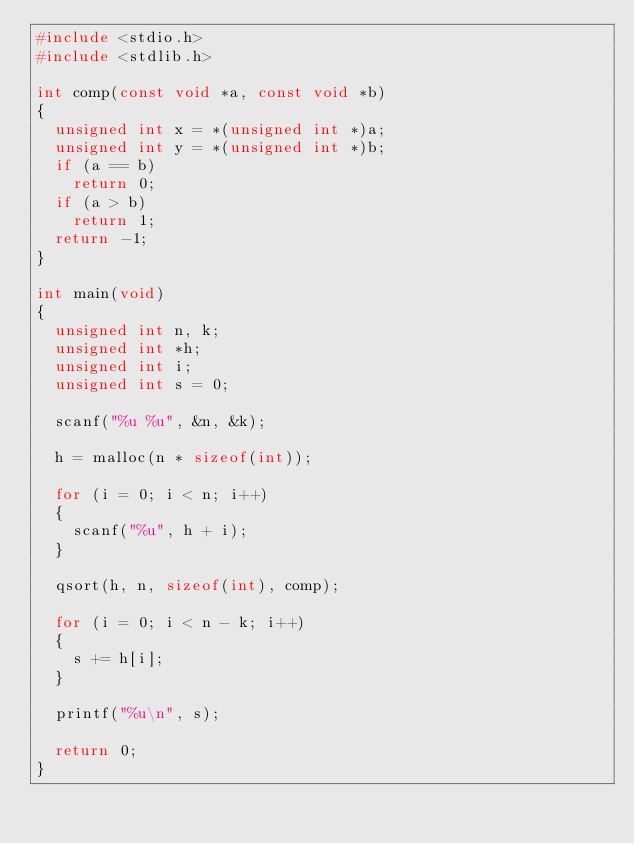<code> <loc_0><loc_0><loc_500><loc_500><_C_>#include <stdio.h>
#include <stdlib.h>

int comp(const void *a, const void *b)
{
	unsigned int x = *(unsigned int *)a;
	unsigned int y = *(unsigned int *)b;
	if (a == b)
		return 0;
	if (a > b)
		return 1;
	return -1;
}

int main(void)
{
	unsigned int n, k;
	unsigned int *h;
	unsigned int i;
	unsigned int s = 0;

	scanf("%u %u", &n, &k);

	h = malloc(n * sizeof(int));

	for (i = 0; i < n; i++)
	{
		scanf("%u", h + i);
	}

	qsort(h, n, sizeof(int), comp);

	for (i = 0; i < n - k; i++)
	{
		s += h[i];
	}

	printf("%u\n", s);

	return 0;
}
</code> 